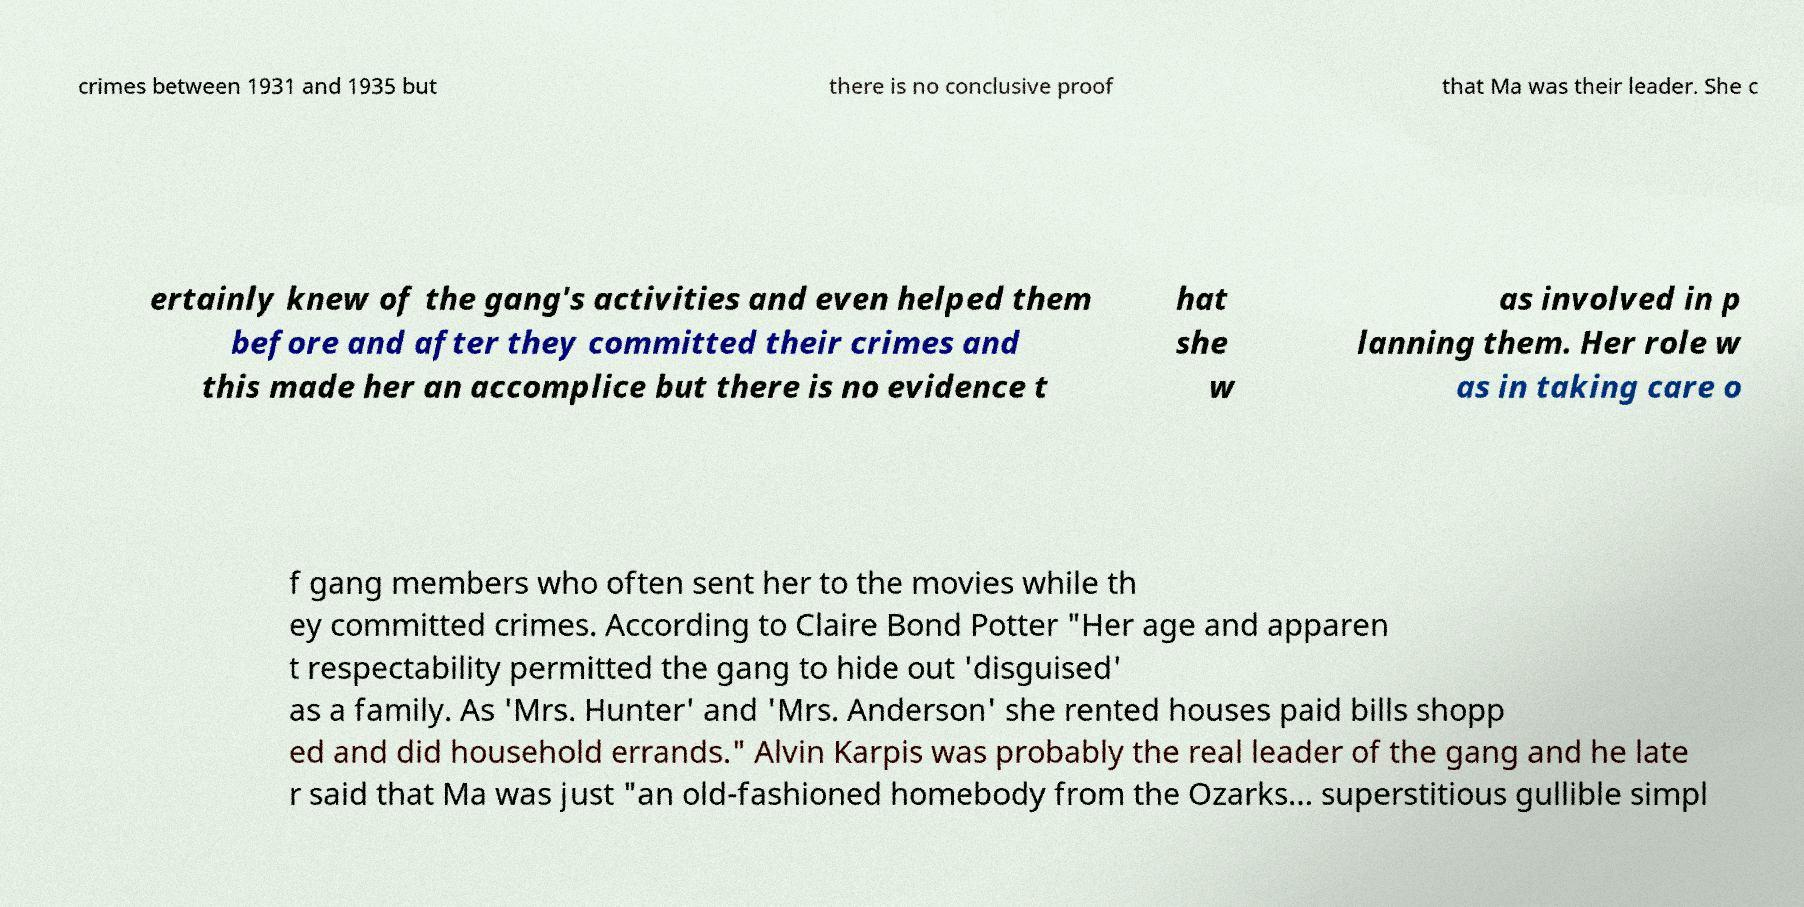I need the written content from this picture converted into text. Can you do that? crimes between 1931 and 1935 but there is no conclusive proof that Ma was their leader. She c ertainly knew of the gang's activities and even helped them before and after they committed their crimes and this made her an accomplice but there is no evidence t hat she w as involved in p lanning them. Her role w as in taking care o f gang members who often sent her to the movies while th ey committed crimes. According to Claire Bond Potter "Her age and apparen t respectability permitted the gang to hide out 'disguised' as a family. As 'Mrs. Hunter' and 'Mrs. Anderson' she rented houses paid bills shopp ed and did household errands." Alvin Karpis was probably the real leader of the gang and he late r said that Ma was just "an old-fashioned homebody from the Ozarks… superstitious gullible simpl 